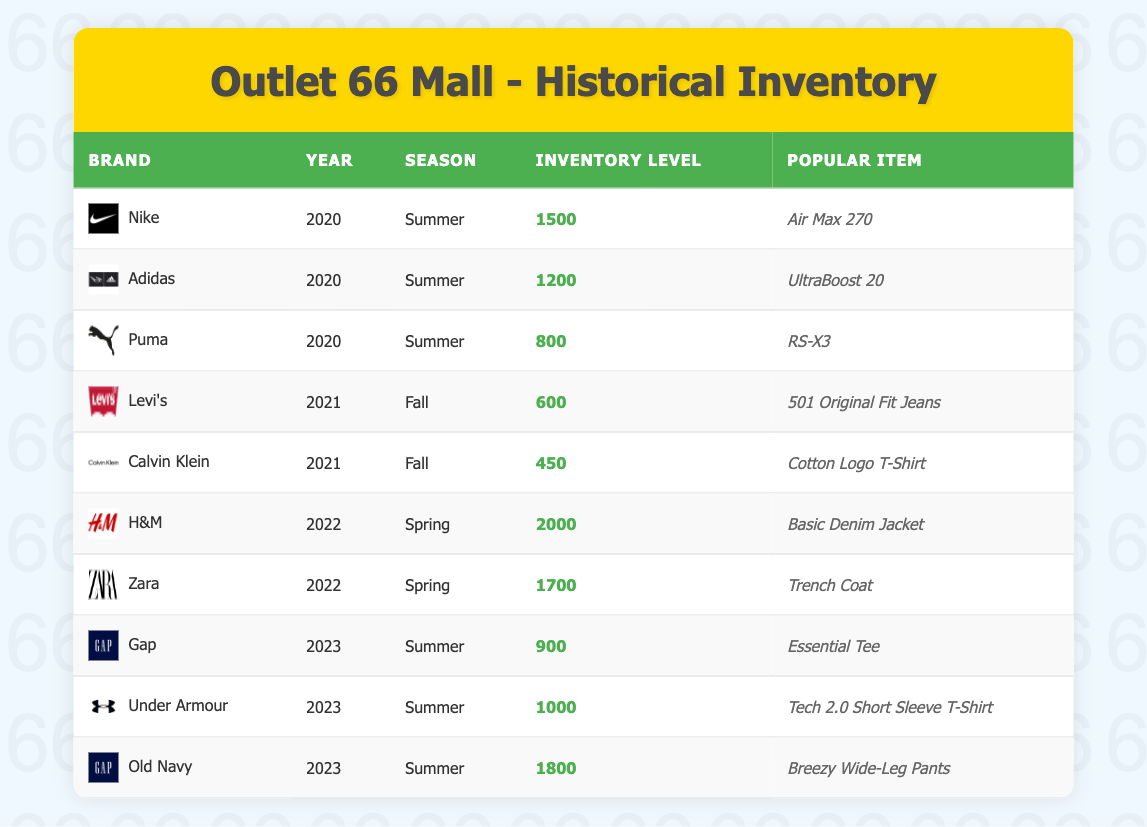What was the inventory level for Nike in Summer 2020? The table shows that in Summer 2020, Nike had an inventory level of 1500.
Answer: 1500 What was the popular item for H&M in Spring 2022? According to the table, the popular item for H&M in Spring 2022 is the Basic Denim Jacket.
Answer: Basic Denim Jacket Which brand had the lowest inventory level in Fall 2021? In Fall 2021, Calvin Klein had the lowest inventory level of 450.
Answer: Calvin Klein How many total inventory units did Old Navy and Under Armour have in Summer 2023 combined? To find the total inventory for Old Navy and Under Armour, add their individual inventory levels: 1800 (Old Navy) + 1000 (Under Armour) = 2800.
Answer: 2800 Was Adidas more popular than Puma in Summer 2020 based on inventory levels? In Summer 2020, Adidas had an inventory level of 1200, and Puma had 800. Since 1200 is greater than 800, it is true that Adidas was more popular than Puma in terms of inventory.
Answer: Yes What year and season had the highest inventory level recorded, and what was that level? The highest inventory level recorded was for H&M in Spring 2022, with an inventory level of 2000. To find this, I reviewed all entries and compared the inventory levels. H&M's level stands out as the highest.
Answer: H&M, Spring 2022, 2000 How many brands recorded an inventory level of 1000 or more in Summer 2023? The brands that had an inventory level of 1000 or more in Summer 2023 are Old Navy (1800), Under Armour (1000), and Nike (1500) from prior data but none in this season. Old Navy and Under Armour recorded. Therefore, there are 2 brands in Summer 2023 that meet this condition.
Answer: 2 Which season in 2022 had more inventory between H&M and Zara and by how much? In Spring 2022, H&M had 2000 and Zara had 1700. The difference in inventory levels is calculated as follows: 2000 - 1700 = 300. Therefore, H&M had 300 more units than Zara in Spring 2022.
Answer: 300 more units What is the average inventory level for brands listed in Summer 2023? For Summer 2023, the inventory levels are: Gap (900), Under Armour (1000), and Old Navy (1800). To calculate the average, first add these levels: 900 + 1000 + 1800 = 3700. Then divide by the number of brands, which is 3: 3700 / 3 = 1233.33. This indicates that the average inventory level for Summer 2023 brands is approximately 1233.33.
Answer: 1233.33 